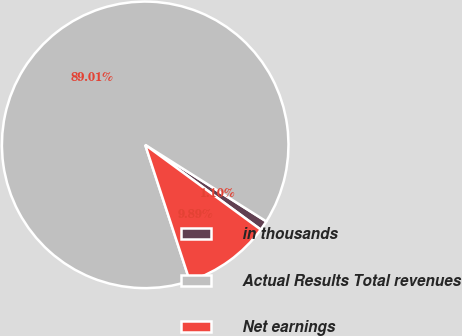Convert chart to OTSL. <chart><loc_0><loc_0><loc_500><loc_500><pie_chart><fcel>in thousands<fcel>Actual Results Total revenues<fcel>Net earnings<nl><fcel>1.1%<fcel>89.0%<fcel>9.89%<nl></chart> 